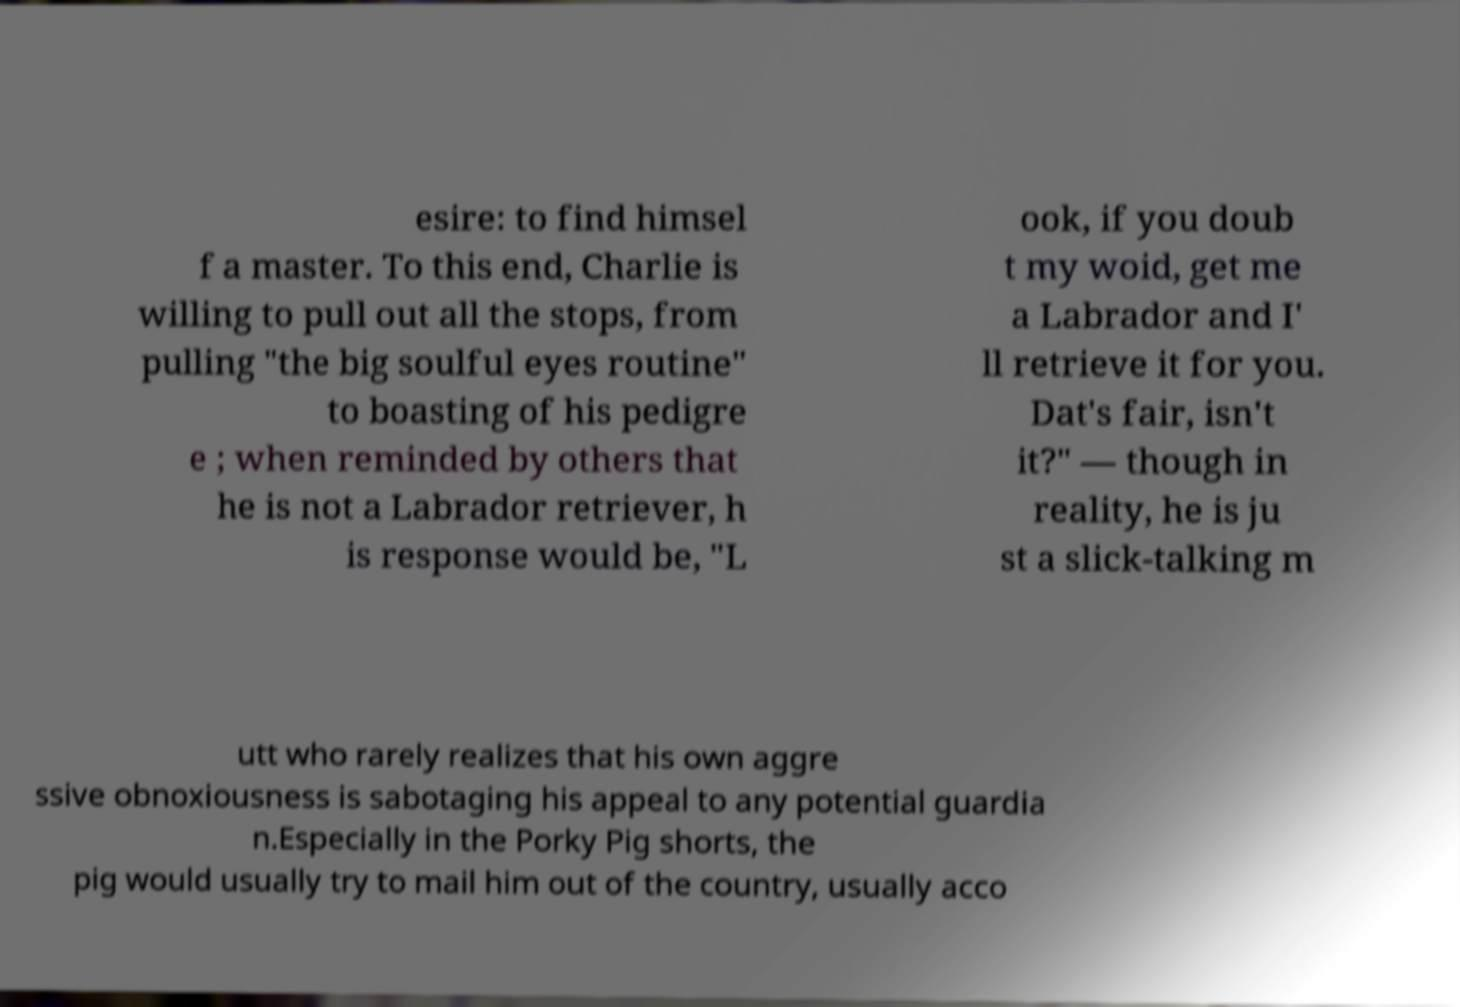I need the written content from this picture converted into text. Can you do that? esire: to find himsel f a master. To this end, Charlie is willing to pull out all the stops, from pulling "the big soulful eyes routine" to boasting of his pedigre e ; when reminded by others that he is not a Labrador retriever, h is response would be, "L ook, if you doub t my woid, get me a Labrador and I' ll retrieve it for you. Dat's fair, isn't it?" — though in reality, he is ju st a slick-talking m utt who rarely realizes that his own aggre ssive obnoxiousness is sabotaging his appeal to any potential guardia n.Especially in the Porky Pig shorts, the pig would usually try to mail him out of the country, usually acco 